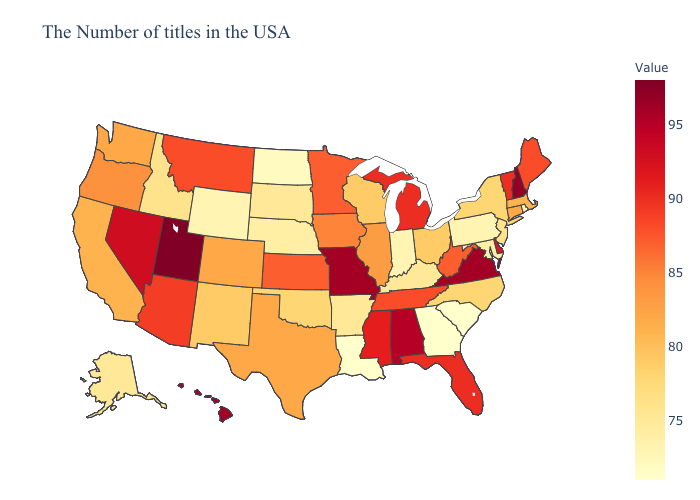Does Michigan have the highest value in the USA?
Quick response, please. No. Does Oklahoma have the highest value in the USA?
Be succinct. No. Does Florida have a higher value than Nebraska?
Short answer required. Yes. Does the map have missing data?
Quick response, please. No. Does Oregon have a higher value than Michigan?
Keep it brief. No. Which states have the lowest value in the USA?
Be succinct. South Carolina, Georgia, Louisiana. 